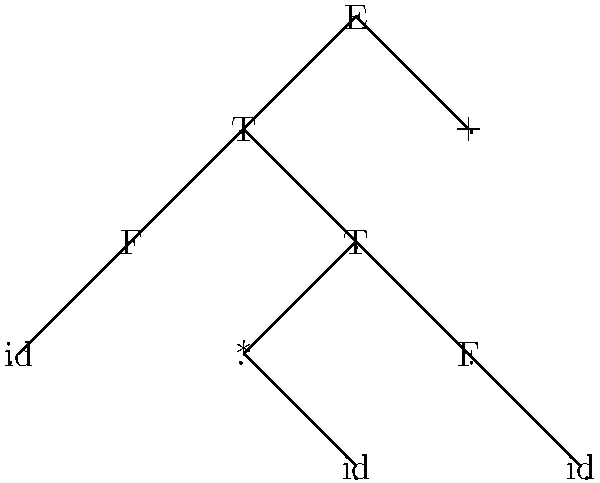Given the parse tree above, which represents the syntactic structure of an arithmetic expression, what is the corresponding infix expression? Assume that the grammar follows standard operator precedence rules. To determine the infix expression from the given parse tree, we need to traverse the tree and construct the expression based on the node labels and their relationships. Let's follow these steps:

1. The root node is labeled 'E' (Expression), which has two children: 'T' and '+'.
2. The left 'T' (Term) node has two children: 'F' (Factor) and 'T'.
3. The 'F' node under the left 'T' has a child labeled 'id' (identifier).
4. The 'T' node to the right of 'F' has two children: '*' and 'F'.
5. The 'F' node under this 'T' has a child labeled 'id'.
6. The right child of the root 'E' is '+', followed by another 'F' node.
7. This rightmost 'F' node has a child labeled 'id'.

Now, let's construct the expression:
- The leftmost 'id' represents the first operand.
- It's followed by '*' and another 'id', forming a multiplication.
- This whole multiplication is then followed by '+' and the last 'id'.

Therefore, the infix expression is: $id * id + id$

Where each 'id' represents a unique identifier or variable in the expression.
Answer: $id * id + id$ 